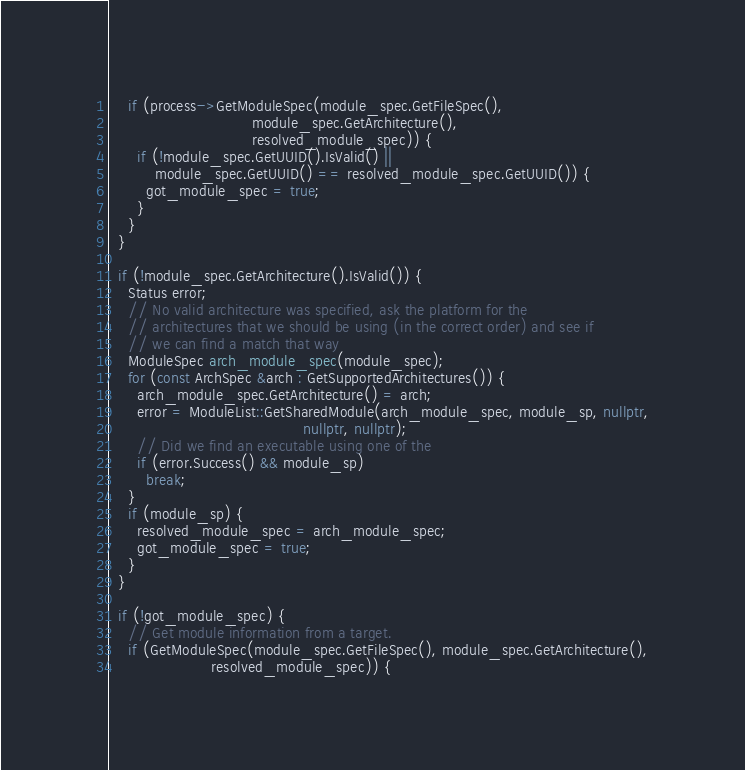<code> <loc_0><loc_0><loc_500><loc_500><_C++_>    if (process->GetModuleSpec(module_spec.GetFileSpec(),
                               module_spec.GetArchitecture(),
                               resolved_module_spec)) {
      if (!module_spec.GetUUID().IsValid() ||
          module_spec.GetUUID() == resolved_module_spec.GetUUID()) {
        got_module_spec = true;
      }
    }
  }

  if (!module_spec.GetArchitecture().IsValid()) {
    Status error;
    // No valid architecture was specified, ask the platform for the
    // architectures that we should be using (in the correct order) and see if
    // we can find a match that way
    ModuleSpec arch_module_spec(module_spec);
    for (const ArchSpec &arch : GetSupportedArchitectures()) {
      arch_module_spec.GetArchitecture() = arch;
      error = ModuleList::GetSharedModule(arch_module_spec, module_sp, nullptr,
                                          nullptr, nullptr);
      // Did we find an executable using one of the
      if (error.Success() && module_sp)
        break;
    }
    if (module_sp) {
      resolved_module_spec = arch_module_spec;
      got_module_spec = true;
    }
  }

  if (!got_module_spec) {
    // Get module information from a target.
    if (GetModuleSpec(module_spec.GetFileSpec(), module_spec.GetArchitecture(),
                      resolved_module_spec)) {</code> 